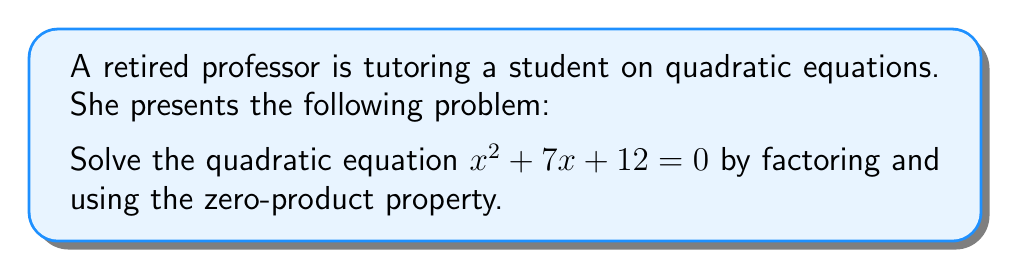Give your solution to this math problem. To solve this quadratic equation, we'll follow these steps:

1) First, we need to factor the left side of the equation:
   $x^2 + 7x + 12 = 0$
   
   We're looking for two numbers that multiply to give 12 and add up to 7.
   These numbers are 3 and 4.

2) We can rewrite the equation as:
   $(x + 3)(x + 4) = 0$

3) Now we can apply the zero-product property. This property states that if the product of factors is zero, then one of the factors must be zero.

4) So, we set each factor to zero and solve:
   $x + 3 = 0$ or $x + 4 = 0$

5) Solving these linear equations:
   $x = -3$ or $x = -4$

Therefore, the solutions to the equation are $x = -3$ and $x = -4$.
Answer: $x = -3, -4$ 